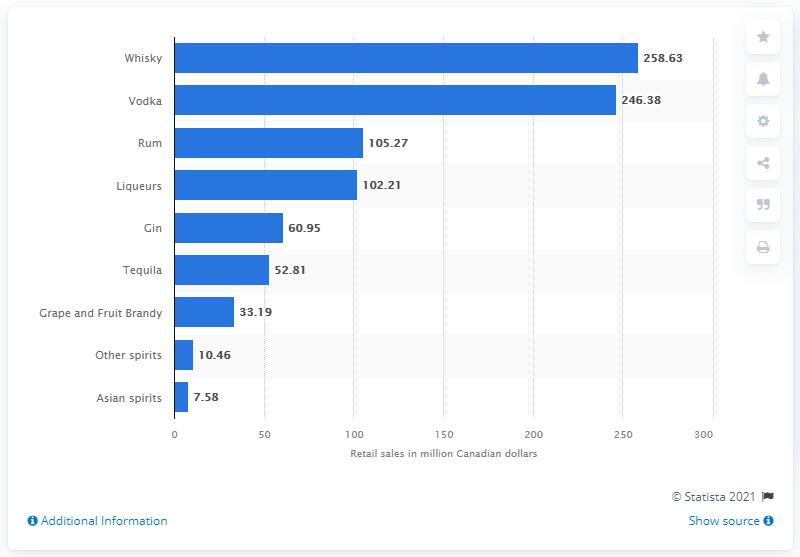List a handful of essential elements in this visual. According to the retail sales data for fiscal year 2020/21 in Colombia, the total amount of vodka sold was 246.38 million units. 